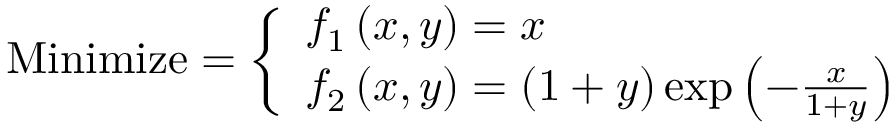Convert formula to latex. <formula><loc_0><loc_0><loc_500><loc_500>{ M i n i m i z e } = { \left \{ \begin{array} { l l } { f _ { 1 } \left ( x , y \right ) = x } \\ { f _ { 2 } \left ( x , y \right ) = \left ( 1 + y \right ) \exp \left ( - { \frac { x } { 1 + y } } \right ) } \end{array} }</formula> 